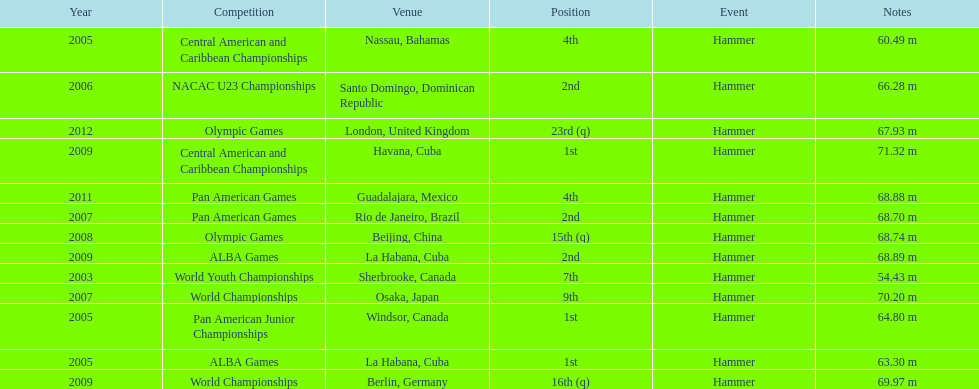What is the number of competitions held in cuba? 3. 